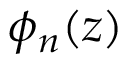<formula> <loc_0><loc_0><loc_500><loc_500>\phi _ { n } ( z )</formula> 